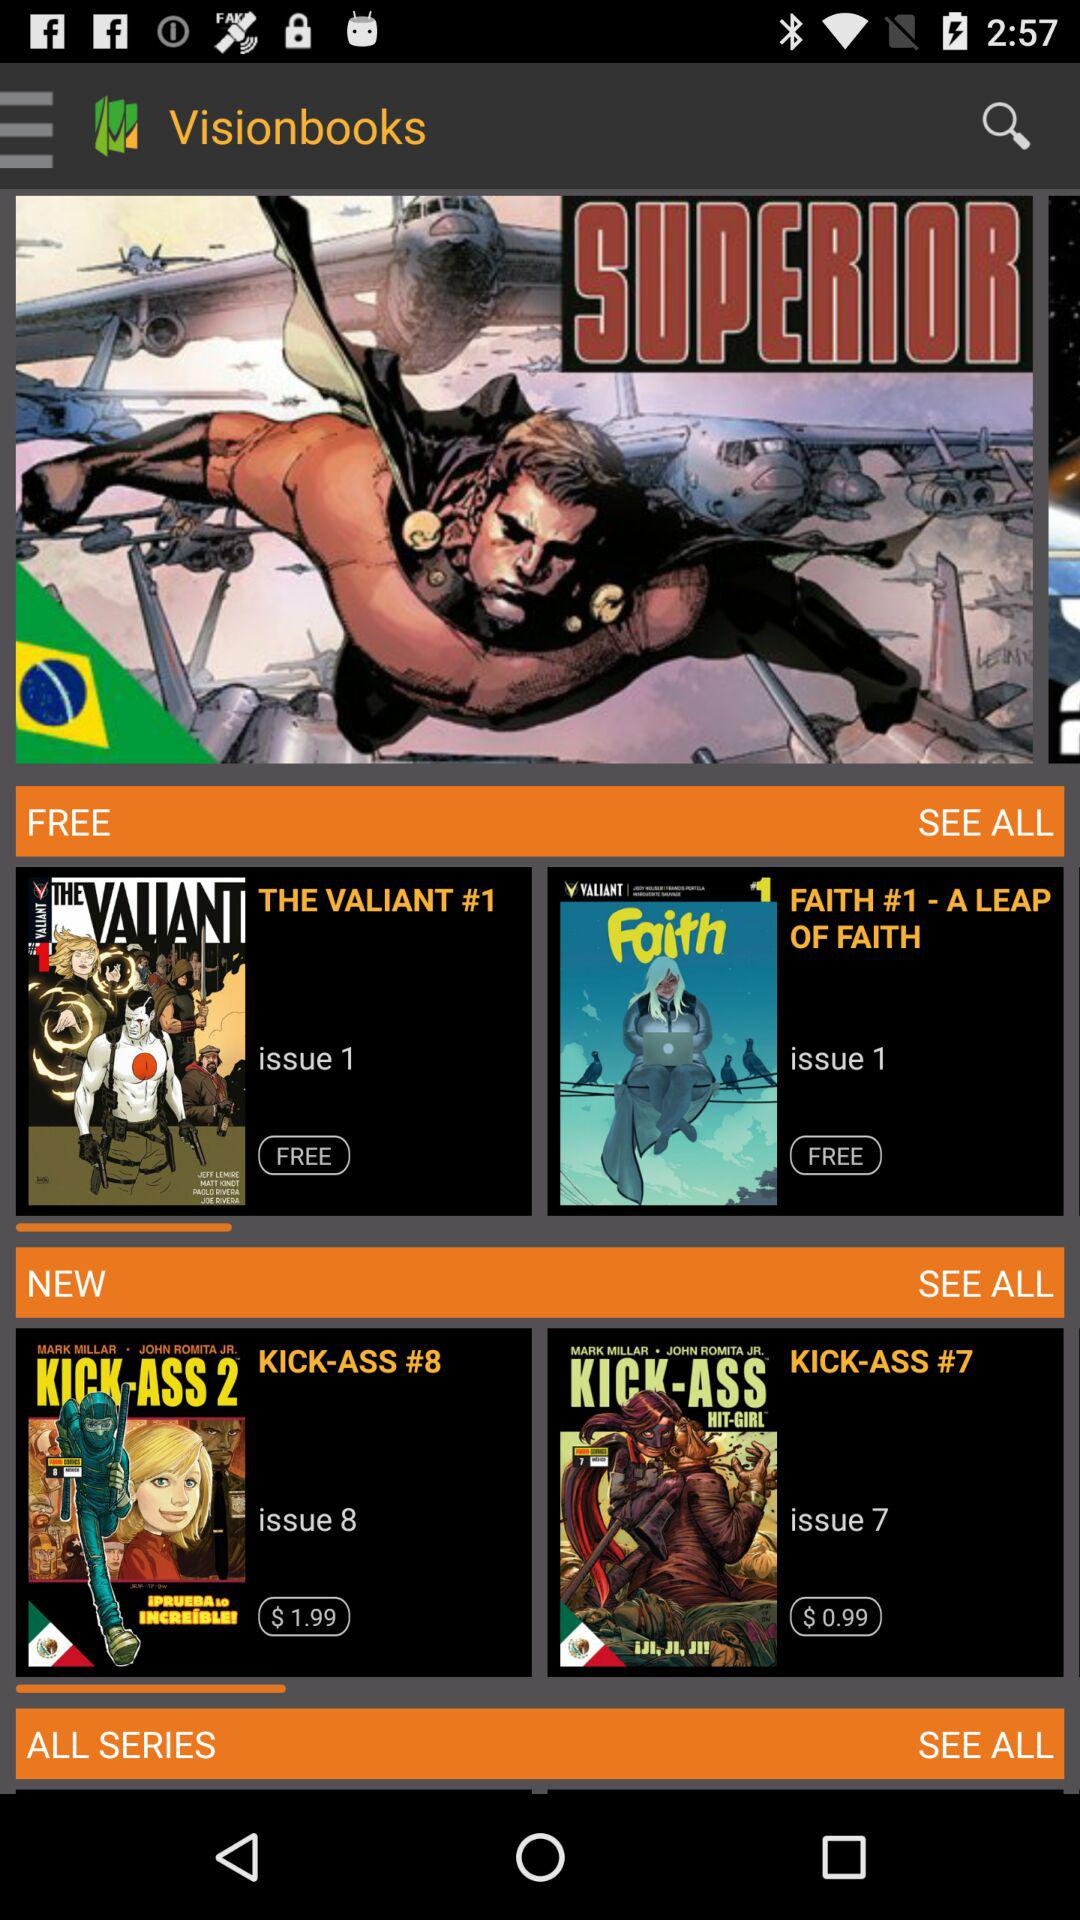What is the price of "KICK-ASS #8"? The price is $1.99. 